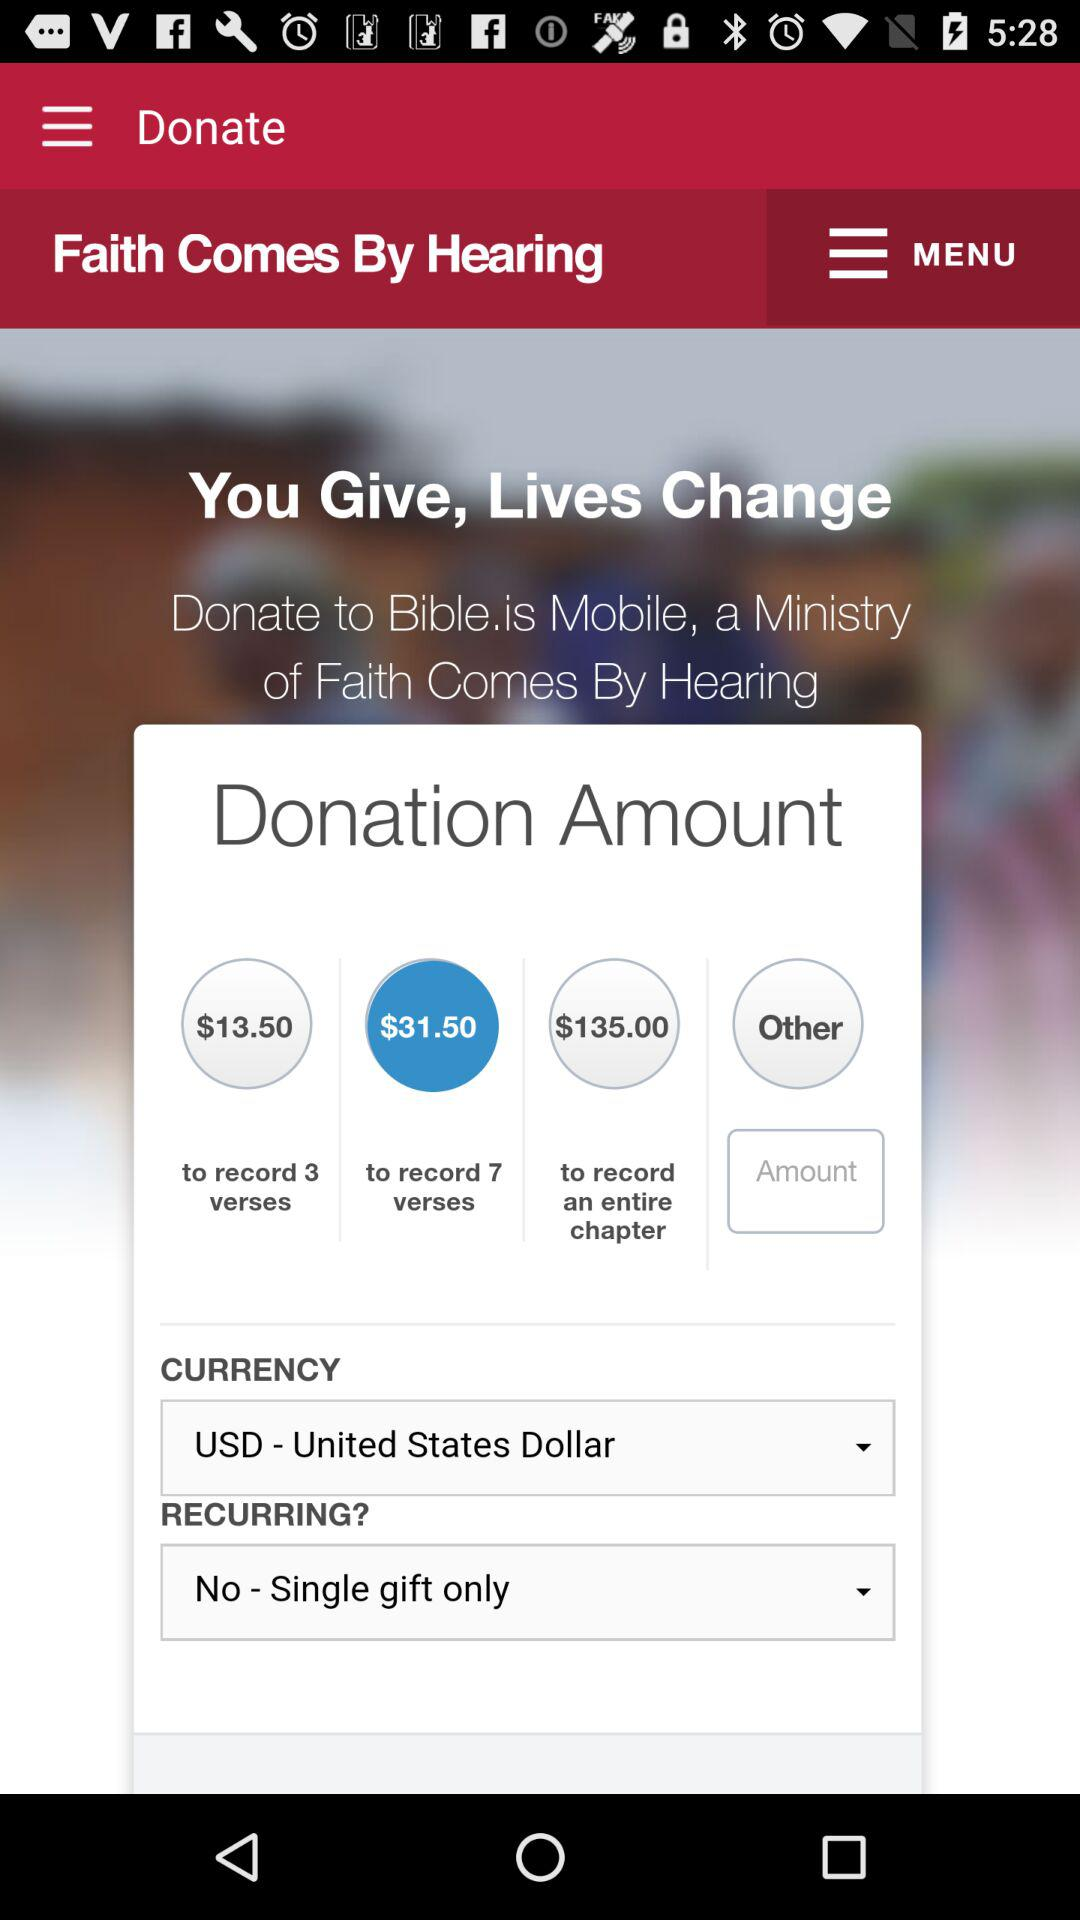What is the donation amount to record 3 verses? The donation amount to record 3 verses is $13.50. 